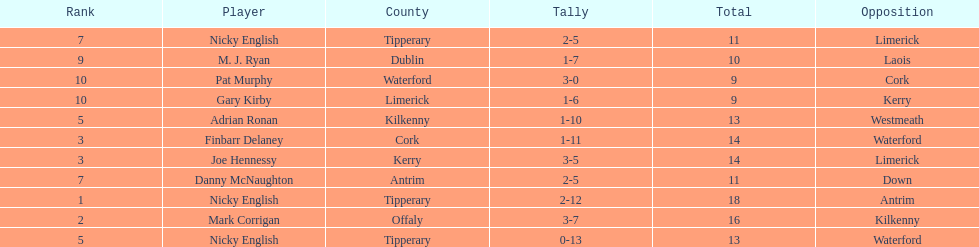Who ranked above mark corrigan? Nicky English. 